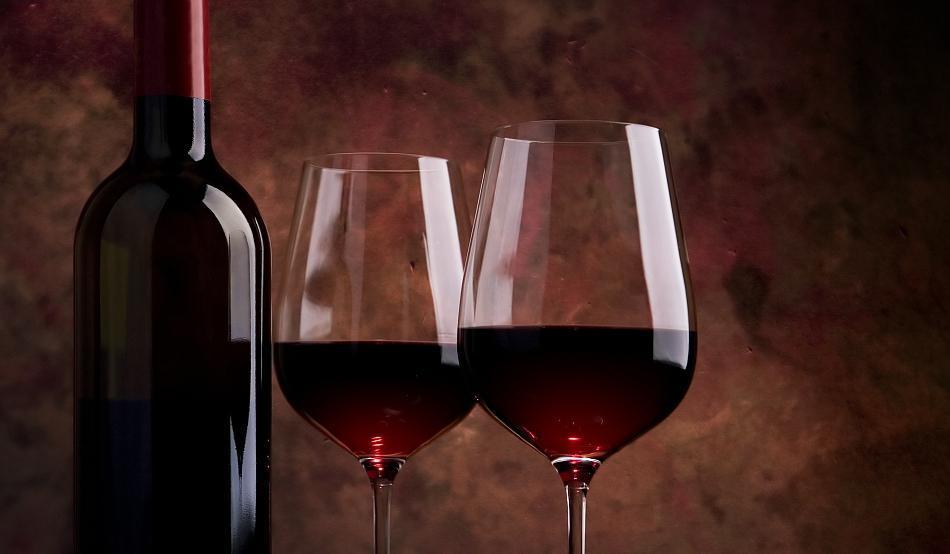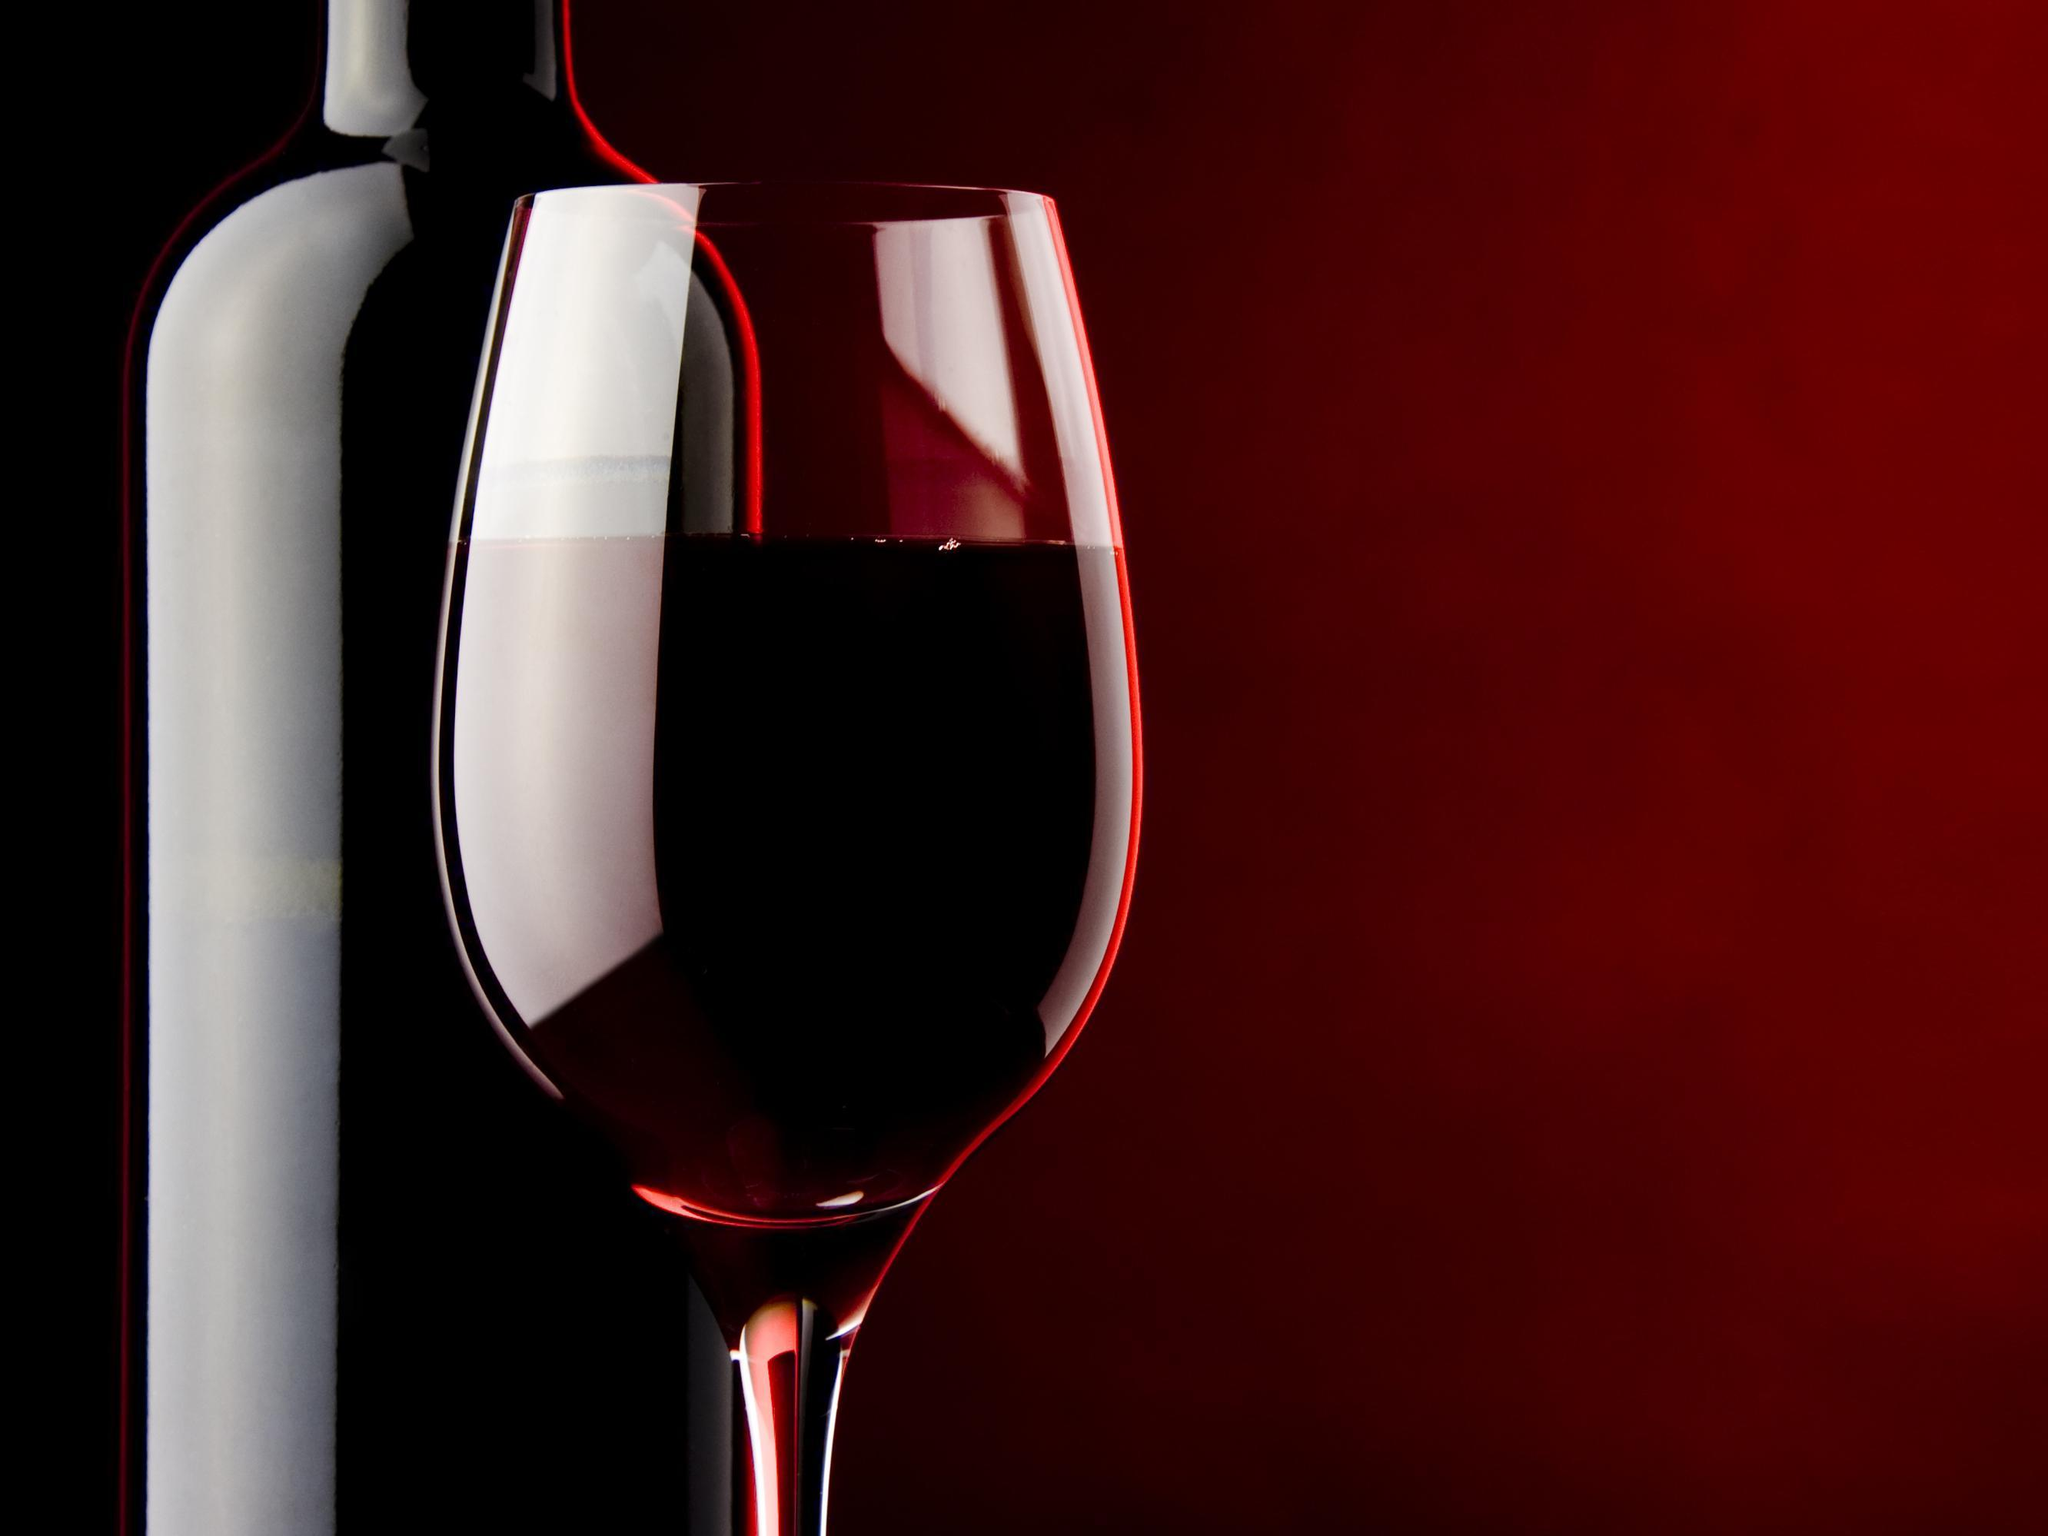The first image is the image on the left, the second image is the image on the right. Examine the images to the left and right. Is the description "The left image features exactly two wine glasses." accurate? Answer yes or no. Yes. 